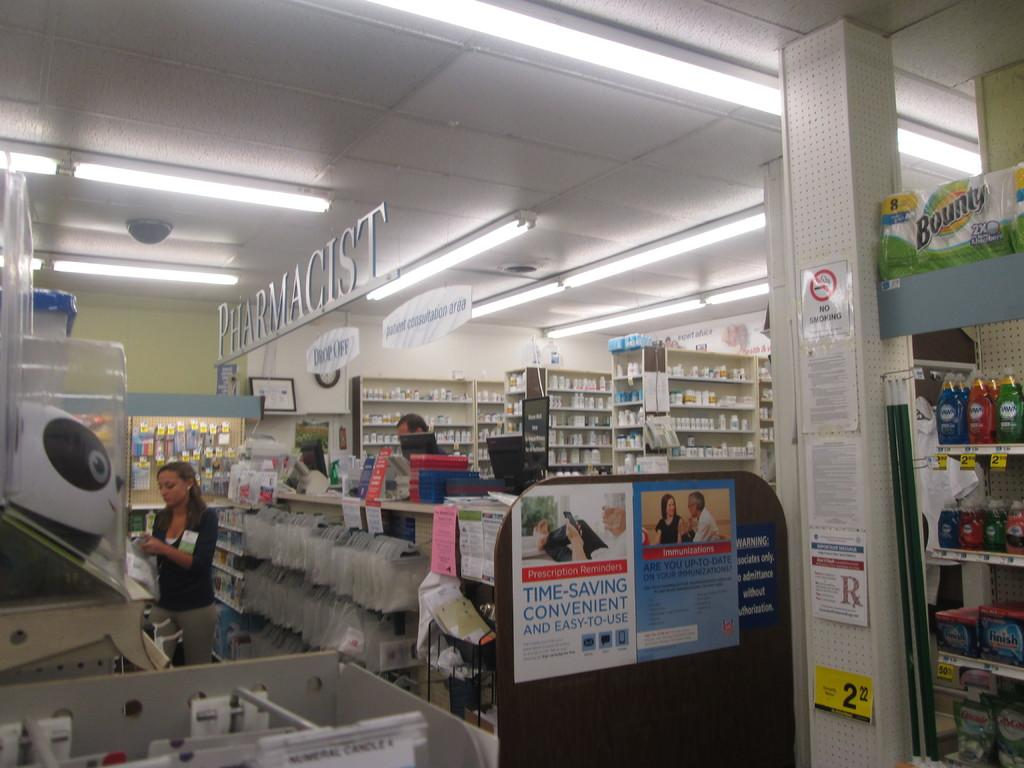<image>
Provide a brief description of the given image. the inside of a store with a sign on the roof that says 'pharmacist' 